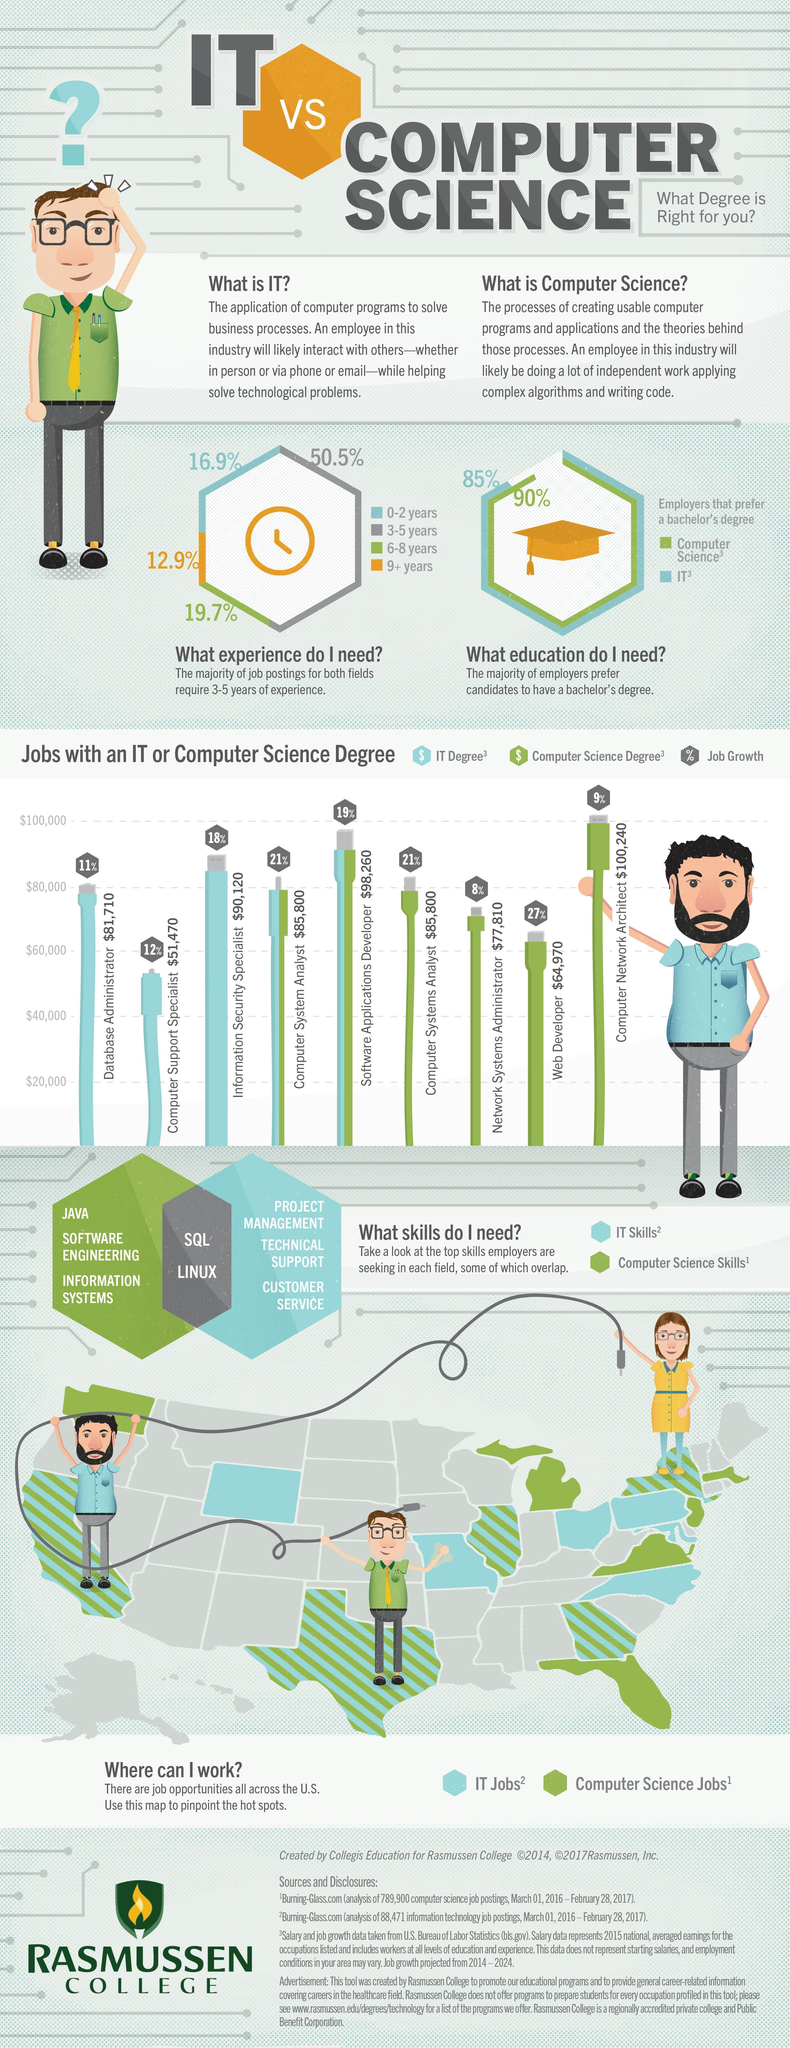Highlight a few significant elements in this photo. According to a recent survey, 85% of employers prefer to hire candidates with a bachelor's degree in Information Technology. Which program has the highest share of users among 6-8 year olds and 3-5 year olds? According to a significant percentage of employers, a bachelor's degree in Computer Science is the preferred or most preferred qualification for a job in the field. Specifically, 90% of employers reported that they prefer or most prefer to hire candidates with a bachelor's degree in Computer Science. According to the data, the combined job growth for web developers and computer system analysts is approximately 48%. The combined job growth for database administrators and computer network architects is expected to be approximately 20%. 